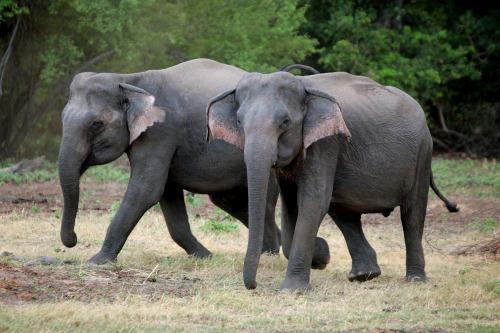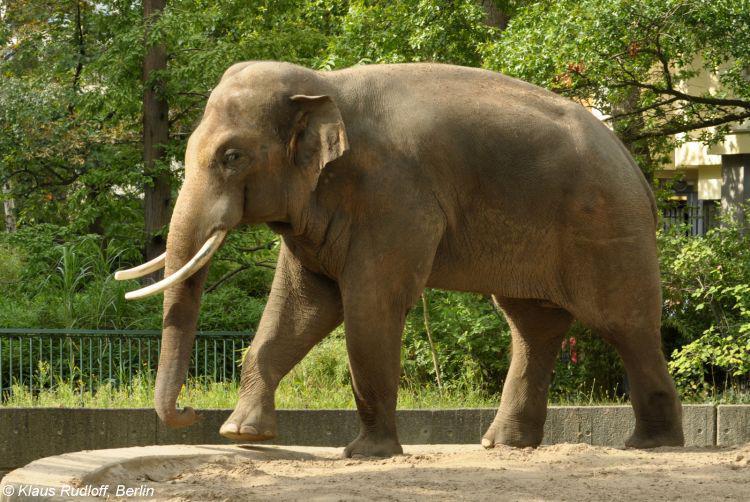The first image is the image on the left, the second image is the image on the right. Analyze the images presented: Is the assertion "There is exactly one elephant in the image on the right." valid? Answer yes or no. Yes. 